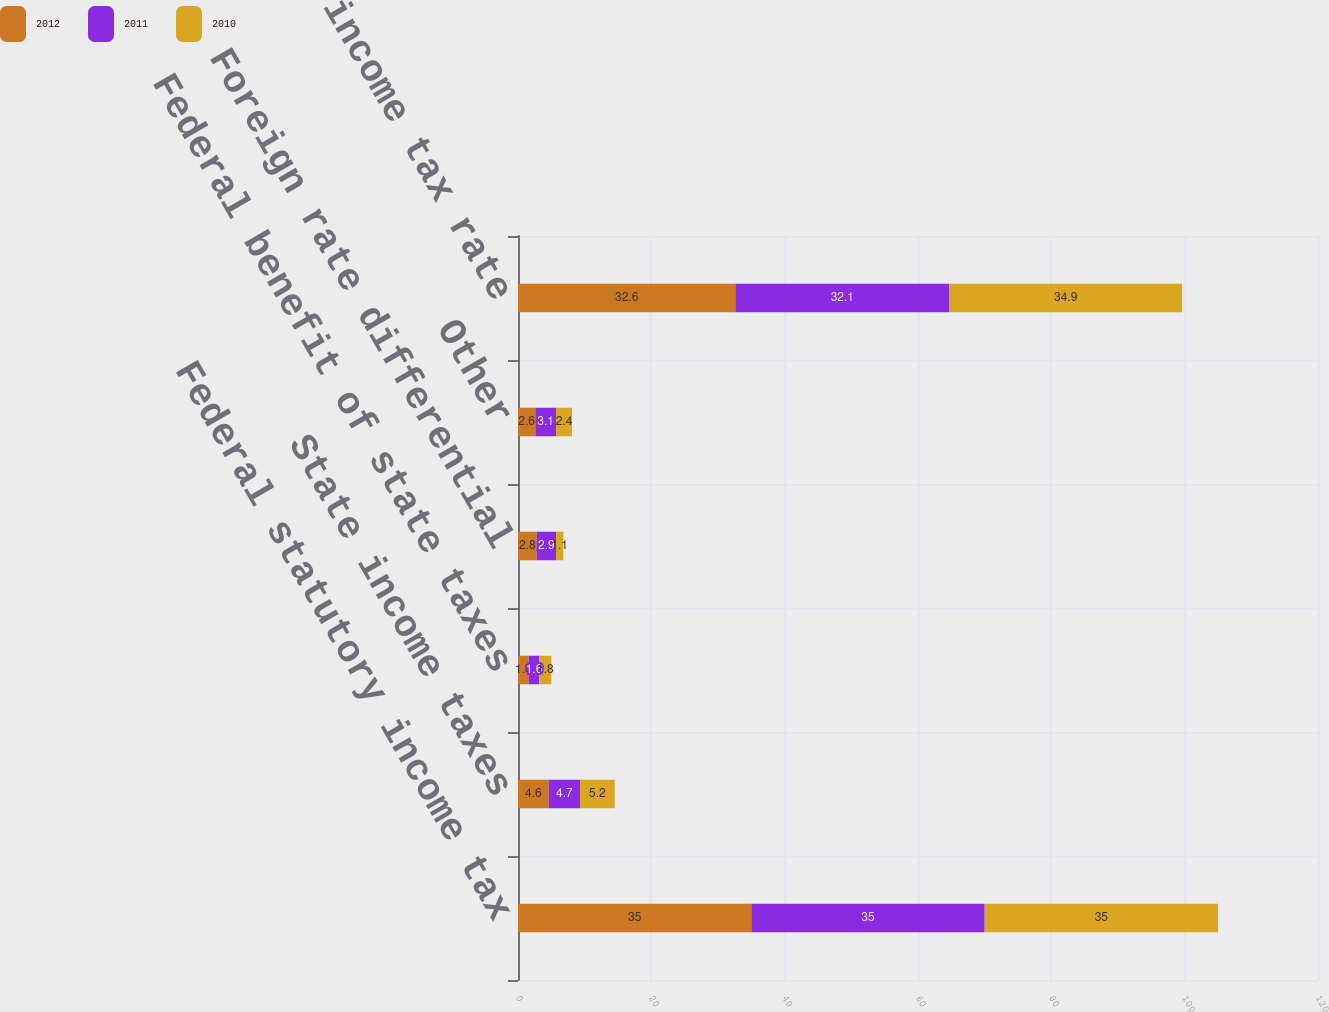Convert chart. <chart><loc_0><loc_0><loc_500><loc_500><stacked_bar_chart><ecel><fcel>Federal statutory income tax<fcel>State income taxes<fcel>Federal benefit of state taxes<fcel>Foreign rate differential<fcel>Other<fcel>Effective income tax rate<nl><fcel>2012<fcel>35<fcel>4.6<fcel>1.6<fcel>2.8<fcel>2.6<fcel>32.6<nl><fcel>2011<fcel>35<fcel>4.7<fcel>1.6<fcel>2.9<fcel>3.1<fcel>32.1<nl><fcel>2010<fcel>35<fcel>5.2<fcel>1.8<fcel>1.1<fcel>2.4<fcel>34.9<nl></chart> 